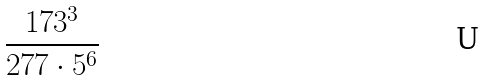Convert formula to latex. <formula><loc_0><loc_0><loc_500><loc_500>\frac { 1 7 3 ^ { 3 } } { 2 7 7 \cdot 5 ^ { 6 } }</formula> 